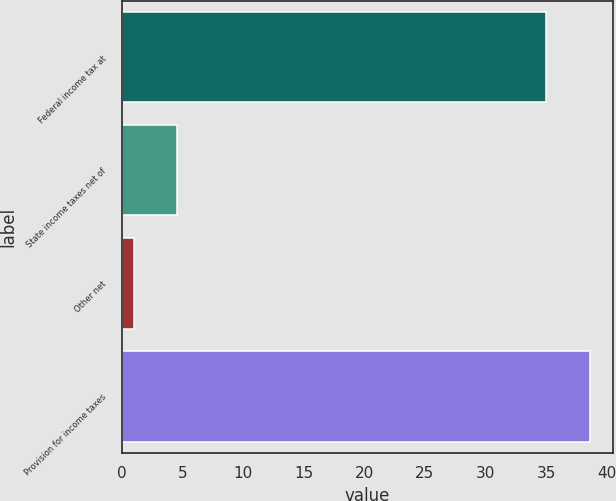Convert chart to OTSL. <chart><loc_0><loc_0><loc_500><loc_500><bar_chart><fcel>Federal income tax at<fcel>State income taxes net of<fcel>Other net<fcel>Provision for income taxes<nl><fcel>35<fcel>4.6<fcel>1<fcel>38.6<nl></chart> 